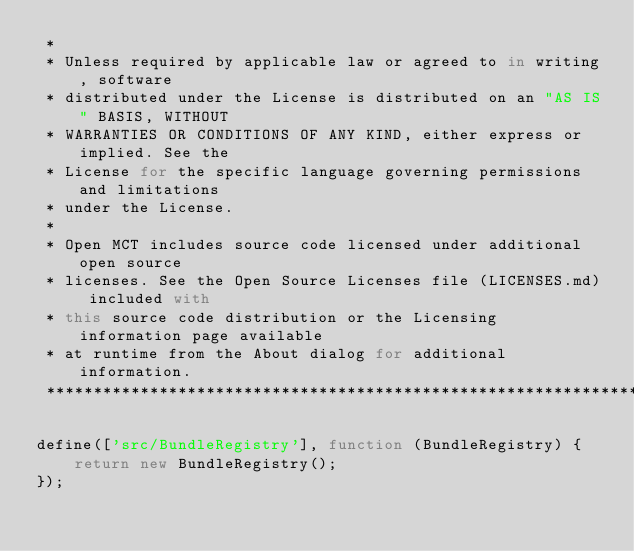Convert code to text. <code><loc_0><loc_0><loc_500><loc_500><_JavaScript_> *
 * Unless required by applicable law or agreed to in writing, software
 * distributed under the License is distributed on an "AS IS" BASIS, WITHOUT
 * WARRANTIES OR CONDITIONS OF ANY KIND, either express or implied. See the
 * License for the specific language governing permissions and limitations
 * under the License.
 *
 * Open MCT includes source code licensed under additional open source
 * licenses. See the Open Source Licenses file (LICENSES.md) included with
 * this source code distribution or the Licensing information page available
 * at runtime from the About dialog for additional information.
 *****************************************************************************/

define(['src/BundleRegistry'], function (BundleRegistry) {
    return new BundleRegistry();
});
</code> 